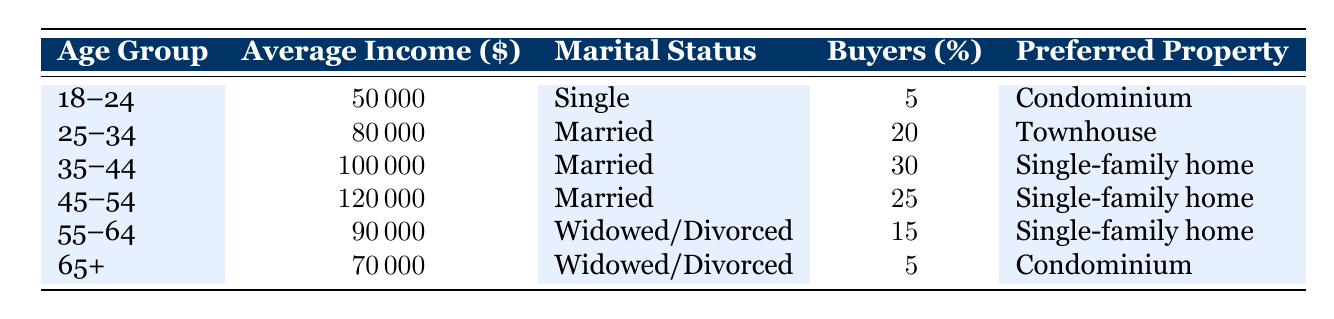What percentage of home buyers are aged 35-44? The table shows that the percentage of buyers aged 35-44 is listed as 30%.
Answer: 30% What is the average income of buyers aged 45-54? According to the table, the average income for buyers in the 45-54 age group is $120,000.
Answer: $120,000 Is the preferred property type for buyers aged 25-34 a condominium? The table indicates that buyers aged 25-34 prefer townhouses, not condominiums.
Answer: No Which age group has the highest percentage of home buyers? The age group with the highest percentage of buyers is 35-44, at 30%.
Answer: 35-44 What is the combined percentage of buyers aged 18-24 and 65+? To find this, we add the percentages: 5% (aged 18-24) + 5% (aged 65+) = 10%.
Answer: 10% What is the average income of all groups of buyers mentioned? To get the average income, we sum the incomes: 50,000 + 80,000 + 100,000 + 120,000 + 90,000 + 70,000 = 510,000 for 6 groups, then divide by 6, giving 85,000.
Answer: $85,000 Does the marital status of buyers aged 55-64 influence their preferred property type? The table lists the marital status for this age group as "Widowed/Divorced," and their preferred property type is a Single-family home. The influence cannot be determined directly from the table.
Answer: No Which group has the lowest average income and what is that income? The group with the lowest average income is 18-24, having an average income of $50,000.
Answer: $50,000 What percentage of buyers prefer Single-family homes? We add the percentages for the 35-44, 45-54, and 55-64 age groups: 30% + 25% + 15% = 70%.
Answer: 70% Is it true that buyers aged 65 and older have a higher percentage of buyers than those aged 25-34? Buyers aged 65+ represent 5% whereas those aged 25-34 represent 20%, so it is false.
Answer: No 